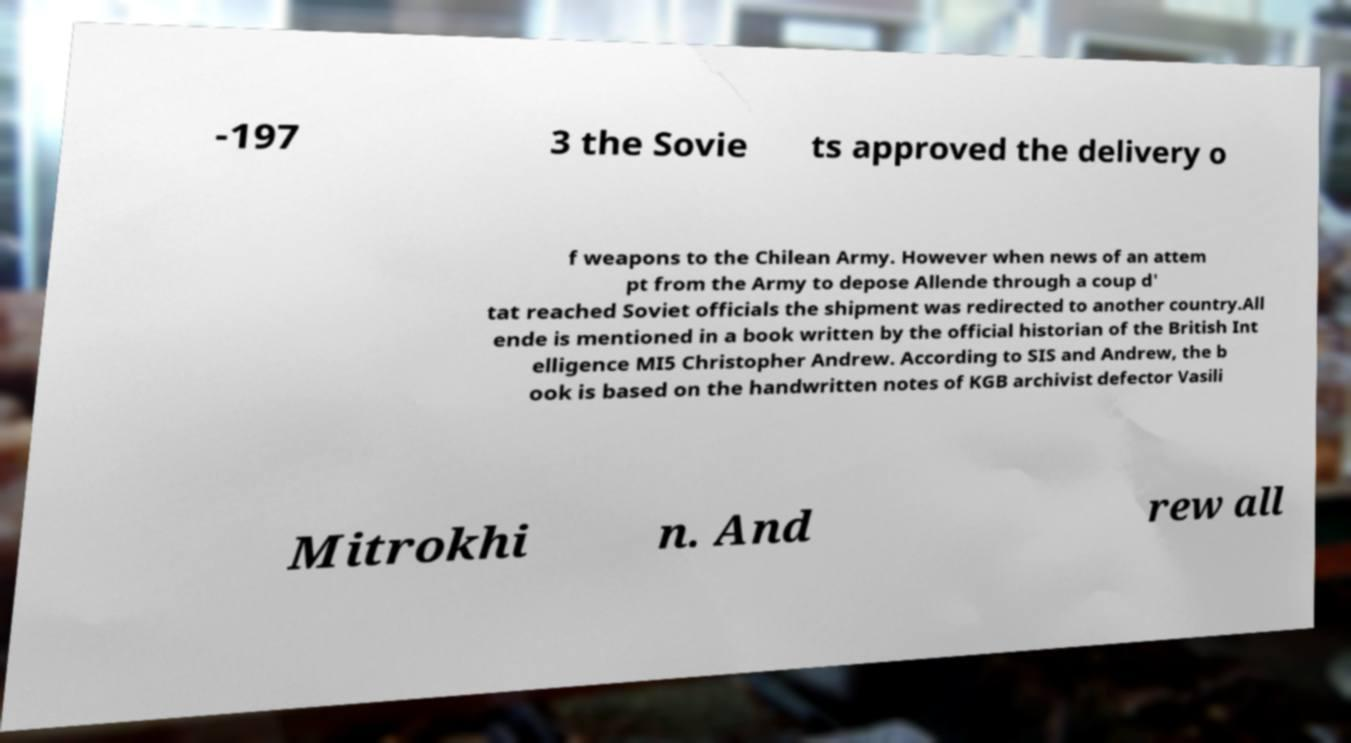There's text embedded in this image that I need extracted. Can you transcribe it verbatim? -197 3 the Sovie ts approved the delivery o f weapons to the Chilean Army. However when news of an attem pt from the Army to depose Allende through a coup d' tat reached Soviet officials the shipment was redirected to another country.All ende is mentioned in a book written by the official historian of the British Int elligence MI5 Christopher Andrew. According to SIS and Andrew, the b ook is based on the handwritten notes of KGB archivist defector Vasili Mitrokhi n. And rew all 